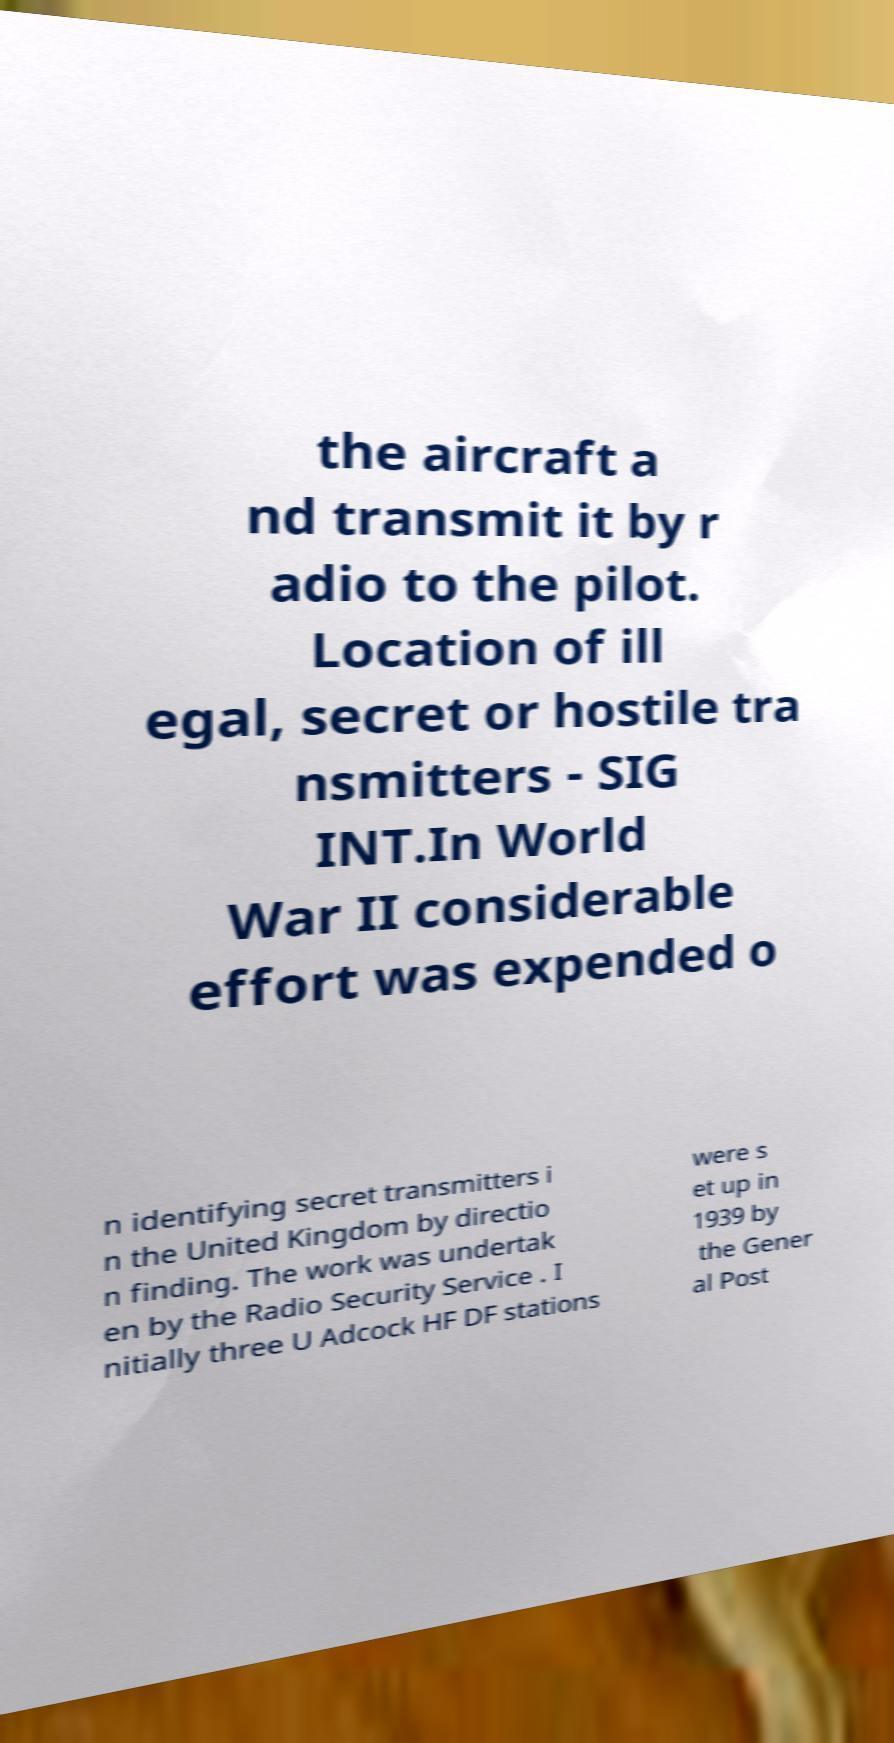I need the written content from this picture converted into text. Can you do that? the aircraft a nd transmit it by r adio to the pilot. Location of ill egal, secret or hostile tra nsmitters - SIG INT.In World War II considerable effort was expended o n identifying secret transmitters i n the United Kingdom by directio n finding. The work was undertak en by the Radio Security Service . I nitially three U Adcock HF DF stations were s et up in 1939 by the Gener al Post 